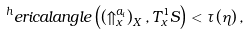<formula> <loc_0><loc_0><loc_500><loc_500>^ { h } e r i c a l a n g l e \left ( \left ( \Uparrow _ { x } ^ { a _ { i } } \right ) _ { X } , T _ { x } ^ { 1 } S \right ) < \tau \left ( \eta \right ) ,</formula> 